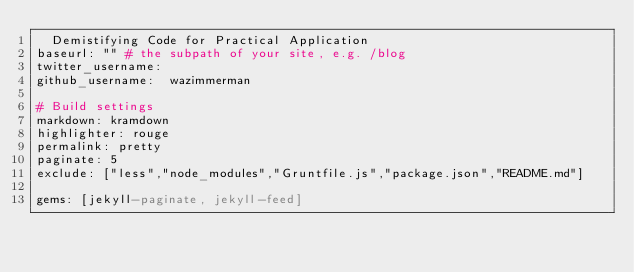Convert code to text. <code><loc_0><loc_0><loc_500><loc_500><_YAML_>  Demistifying Code for Practical Application
baseurl: "" # the subpath of your site, e.g. /blog
twitter_username: 
github_username:  wazimmerman

# Build settings
markdown: kramdown
highlighter: rouge
permalink: pretty
paginate: 5
exclude: ["less","node_modules","Gruntfile.js","package.json","README.md"]

gems: [jekyll-paginate, jekyll-feed]
</code> 